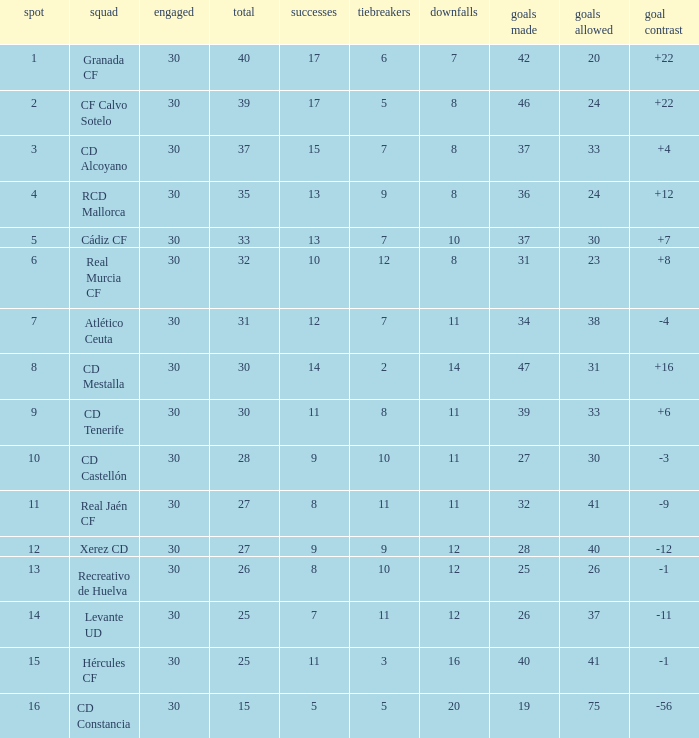How many Draws have 30 Points, and less than 33 Goals against? 1.0. 